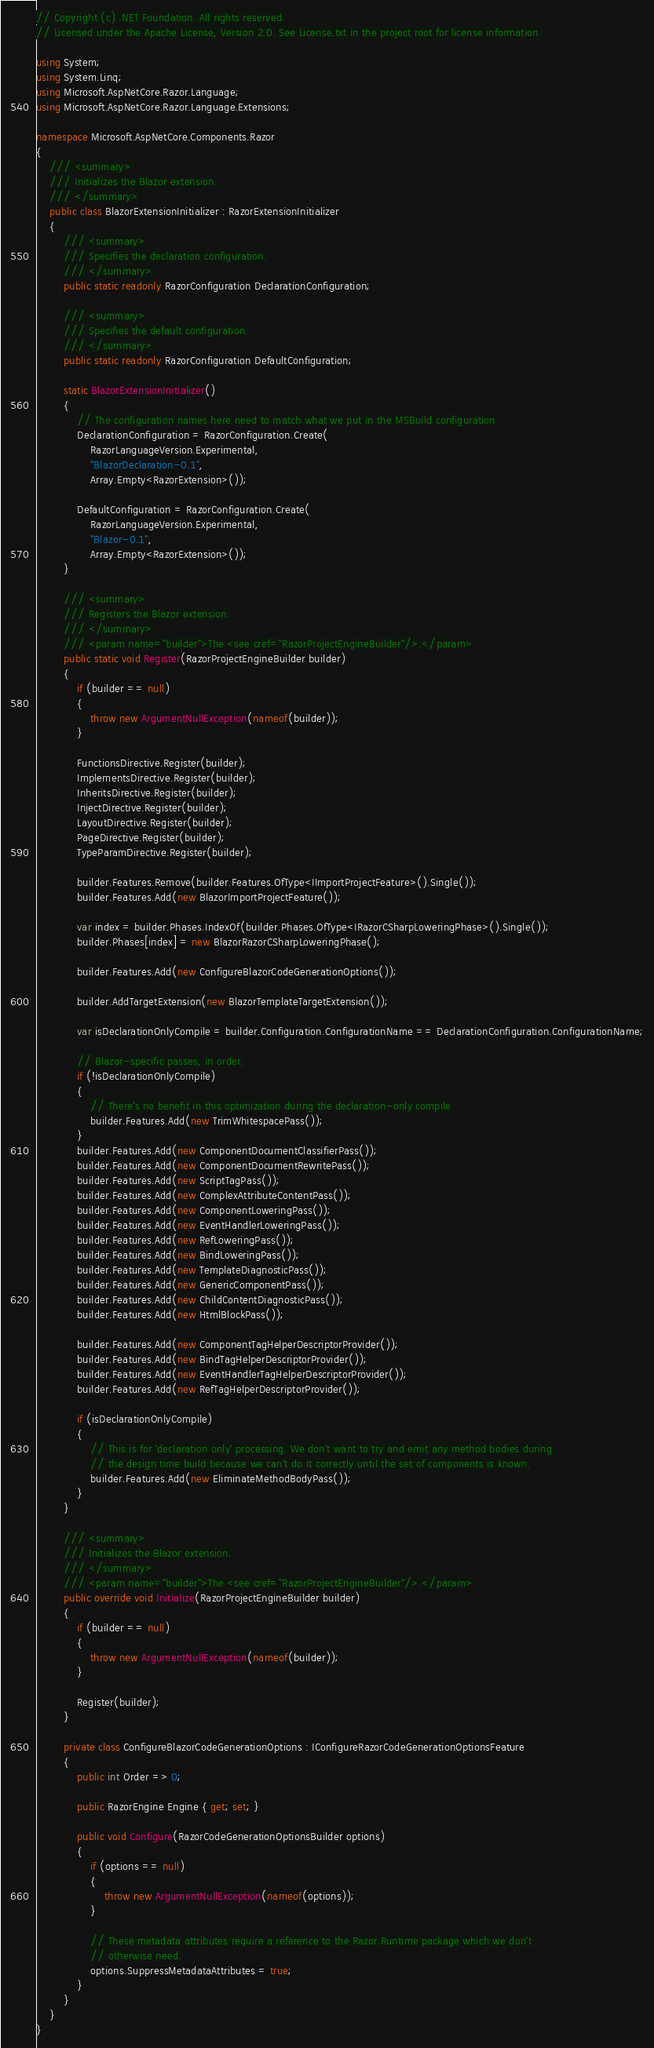<code> <loc_0><loc_0><loc_500><loc_500><_C#_>// Copyright (c) .NET Foundation. All rights reserved.
// Licensed under the Apache License, Version 2.0. See License.txt in the project root for license information.

using System;
using System.Linq;
using Microsoft.AspNetCore.Razor.Language;
using Microsoft.AspNetCore.Razor.Language.Extensions;

namespace Microsoft.AspNetCore.Components.Razor
{
    /// <summary>
    /// Initializes the Blazor extension.
    /// </summary>
    public class BlazorExtensionInitializer : RazorExtensionInitializer
    {
        /// <summary>
        /// Specifies the declaration configuration.
        /// </summary>
        public static readonly RazorConfiguration DeclarationConfiguration;

        /// <summary>
        /// Specifies the default configuration.
        /// </summary>
        public static readonly RazorConfiguration DefaultConfiguration;

        static BlazorExtensionInitializer()
        {
            // The configuration names here need to match what we put in the MSBuild configuration
            DeclarationConfiguration = RazorConfiguration.Create(
                RazorLanguageVersion.Experimental,
                "BlazorDeclaration-0.1",
                Array.Empty<RazorExtension>());

            DefaultConfiguration = RazorConfiguration.Create(
                RazorLanguageVersion.Experimental,
                "Blazor-0.1",
                Array.Empty<RazorExtension>());
        }

        /// <summary>
        /// Registers the Blazor extension.
        /// </summary>
        /// <param name="builder">The <see cref="RazorProjectEngineBuilder"/>.</param>
        public static void Register(RazorProjectEngineBuilder builder)
        {
            if (builder == null)
            {
                throw new ArgumentNullException(nameof(builder));
            }

            FunctionsDirective.Register(builder);
            ImplementsDirective.Register(builder);
            InheritsDirective.Register(builder);
            InjectDirective.Register(builder);
            LayoutDirective.Register(builder);
            PageDirective.Register(builder);
            TypeParamDirective.Register(builder);

            builder.Features.Remove(builder.Features.OfType<IImportProjectFeature>().Single());
            builder.Features.Add(new BlazorImportProjectFeature());

            var index = builder.Phases.IndexOf(builder.Phases.OfType<IRazorCSharpLoweringPhase>().Single());
            builder.Phases[index] = new BlazorRazorCSharpLoweringPhase();

            builder.Features.Add(new ConfigureBlazorCodeGenerationOptions());

            builder.AddTargetExtension(new BlazorTemplateTargetExtension());

            var isDeclarationOnlyCompile = builder.Configuration.ConfigurationName == DeclarationConfiguration.ConfigurationName;

            // Blazor-specific passes, in order.
            if (!isDeclarationOnlyCompile)
            {
                // There's no benefit in this optimization during the declaration-only compile
                builder.Features.Add(new TrimWhitespacePass());
            }
            builder.Features.Add(new ComponentDocumentClassifierPass());
            builder.Features.Add(new ComponentDocumentRewritePass());
            builder.Features.Add(new ScriptTagPass());
            builder.Features.Add(new ComplexAttributeContentPass());
            builder.Features.Add(new ComponentLoweringPass());
            builder.Features.Add(new EventHandlerLoweringPass());
            builder.Features.Add(new RefLoweringPass());
            builder.Features.Add(new BindLoweringPass());
            builder.Features.Add(new TemplateDiagnosticPass());
            builder.Features.Add(new GenericComponentPass());
            builder.Features.Add(new ChildContentDiagnosticPass());
            builder.Features.Add(new HtmlBlockPass());

            builder.Features.Add(new ComponentTagHelperDescriptorProvider());
            builder.Features.Add(new BindTagHelperDescriptorProvider());
            builder.Features.Add(new EventHandlerTagHelperDescriptorProvider());
            builder.Features.Add(new RefTagHelperDescriptorProvider());

            if (isDeclarationOnlyCompile)
            {
                // This is for 'declaration only' processing. We don't want to try and emit any method bodies during
                // the design time build because we can't do it correctly until the set of components is known.
                builder.Features.Add(new EliminateMethodBodyPass());
            }
        }

        /// <summary>
        /// Initializes the Blazor extension.
        /// </summary>
        /// <param name="builder">The <see cref="RazorProjectEngineBuilder"/>.</param>
        public override void Initialize(RazorProjectEngineBuilder builder)
        {
            if (builder == null)
            {
                throw new ArgumentNullException(nameof(builder));
            }

            Register(builder);
        }

        private class ConfigureBlazorCodeGenerationOptions : IConfigureRazorCodeGenerationOptionsFeature
        {
            public int Order => 0;

            public RazorEngine Engine { get; set; }

            public void Configure(RazorCodeGenerationOptionsBuilder options)
            {
                if (options == null)
                {
                    throw new ArgumentNullException(nameof(options));
                }

                // These metadata attributes require a reference to the Razor.Runtime package which we don't
                // otherwise need.
                options.SuppressMetadataAttributes = true;
            }
        }
    }
}
</code> 